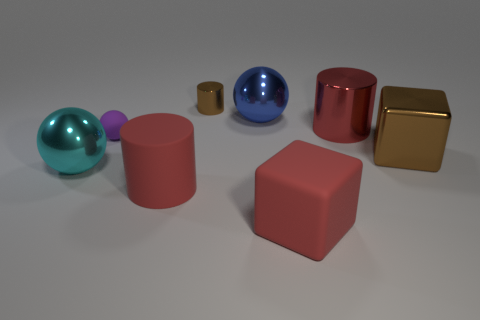Subtract all metallic balls. How many balls are left? 1 Subtract all brown blocks. How many blocks are left? 1 Subtract 1 spheres. How many spheres are left? 2 Add 1 rubber cubes. How many objects exist? 9 Subtract all spheres. How many objects are left? 5 Subtract all red balls. Subtract all gray blocks. How many balls are left? 3 Subtract all cyan spheres. How many brown cylinders are left? 1 Subtract all big red objects. Subtract all blue matte blocks. How many objects are left? 5 Add 4 small brown metallic objects. How many small brown metallic objects are left? 5 Add 1 green metal spheres. How many green metal spheres exist? 1 